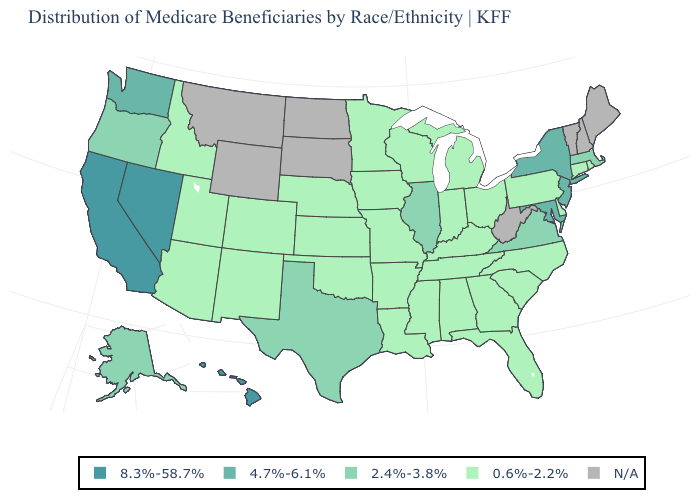Which states have the highest value in the USA?
Keep it brief. California, Hawaii, Nevada. Which states have the highest value in the USA?
Quick response, please. California, Hawaii, Nevada. Name the states that have a value in the range 8.3%-58.7%?
Quick response, please. California, Hawaii, Nevada. What is the value of Maine?
Give a very brief answer. N/A. What is the lowest value in states that border Nevada?
Quick response, please. 0.6%-2.2%. Name the states that have a value in the range 8.3%-58.7%?
Keep it brief. California, Hawaii, Nevada. Does Nevada have the highest value in the West?
Concise answer only. Yes. Name the states that have a value in the range 2.4%-3.8%?
Give a very brief answer. Alaska, Illinois, Massachusetts, Oregon, Texas, Virginia. Name the states that have a value in the range 8.3%-58.7%?
Short answer required. California, Hawaii, Nevada. Name the states that have a value in the range 8.3%-58.7%?
Quick response, please. California, Hawaii, Nevada. Name the states that have a value in the range 8.3%-58.7%?
Quick response, please. California, Hawaii, Nevada. Name the states that have a value in the range 4.7%-6.1%?
Be succinct. Maryland, New Jersey, New York, Washington. 